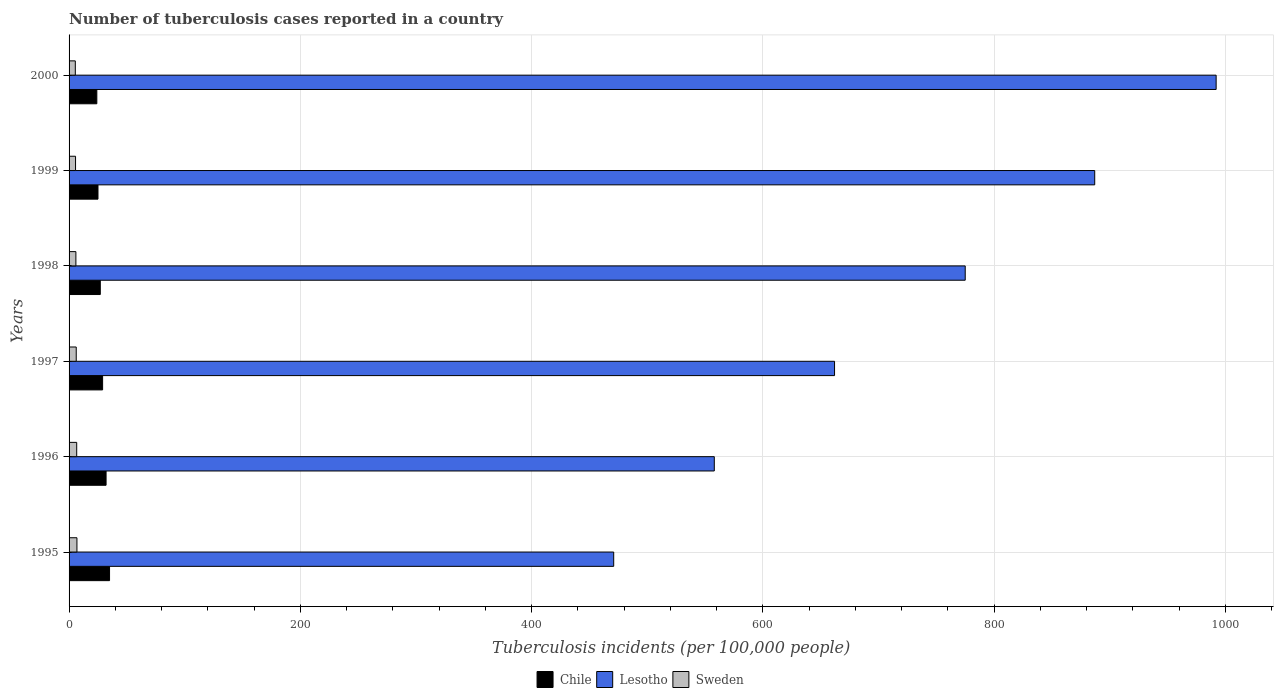How many groups of bars are there?
Keep it short and to the point. 6. Are the number of bars on each tick of the Y-axis equal?
Your answer should be very brief. Yes. How many bars are there on the 6th tick from the top?
Keep it short and to the point. 3. How many bars are there on the 4th tick from the bottom?
Provide a succinct answer. 3. What is the label of the 4th group of bars from the top?
Keep it short and to the point. 1997. What is the number of tuberculosis cases reported in in Chile in 1997?
Provide a succinct answer. 29. Across all years, what is the maximum number of tuberculosis cases reported in in Lesotho?
Offer a terse response. 992. Across all years, what is the minimum number of tuberculosis cases reported in in Chile?
Make the answer very short. 24. What is the total number of tuberculosis cases reported in in Sweden in the graph?
Give a very brief answer. 36.5. What is the difference between the number of tuberculosis cases reported in in Sweden in 1995 and that in 1997?
Keep it short and to the point. 0.6. What is the difference between the number of tuberculosis cases reported in in Chile in 1998 and the number of tuberculosis cases reported in in Sweden in 1997?
Keep it short and to the point. 20.8. What is the average number of tuberculosis cases reported in in Sweden per year?
Your answer should be very brief. 6.08. In the year 1997, what is the difference between the number of tuberculosis cases reported in in Sweden and number of tuberculosis cases reported in in Lesotho?
Ensure brevity in your answer.  -655.8. What is the ratio of the number of tuberculosis cases reported in in Chile in 1996 to that in 1999?
Give a very brief answer. 1.28. Is the number of tuberculosis cases reported in in Lesotho in 1995 less than that in 1999?
Offer a terse response. Yes. What is the difference between the highest and the lowest number of tuberculosis cases reported in in Sweden?
Your response must be concise. 1.4. In how many years, is the number of tuberculosis cases reported in in Chile greater than the average number of tuberculosis cases reported in in Chile taken over all years?
Provide a short and direct response. 3. Is the sum of the number of tuberculosis cases reported in in Chile in 1996 and 1998 greater than the maximum number of tuberculosis cases reported in in Sweden across all years?
Give a very brief answer. Yes. What does the 3rd bar from the bottom in 1996 represents?
Make the answer very short. Sweden. Is it the case that in every year, the sum of the number of tuberculosis cases reported in in Lesotho and number of tuberculosis cases reported in in Sweden is greater than the number of tuberculosis cases reported in in Chile?
Provide a short and direct response. Yes. Are all the bars in the graph horizontal?
Your response must be concise. Yes. What is the difference between two consecutive major ticks on the X-axis?
Give a very brief answer. 200. Are the values on the major ticks of X-axis written in scientific E-notation?
Offer a very short reply. No. Does the graph contain any zero values?
Your answer should be compact. No. Where does the legend appear in the graph?
Provide a short and direct response. Bottom center. How are the legend labels stacked?
Your answer should be compact. Horizontal. What is the title of the graph?
Make the answer very short. Number of tuberculosis cases reported in a country. Does "Singapore" appear as one of the legend labels in the graph?
Your response must be concise. No. What is the label or title of the X-axis?
Your answer should be very brief. Tuberculosis incidents (per 100,0 people). What is the label or title of the Y-axis?
Your answer should be very brief. Years. What is the Tuberculosis incidents (per 100,000 people) in Chile in 1995?
Offer a very short reply. 35. What is the Tuberculosis incidents (per 100,000 people) of Lesotho in 1995?
Provide a short and direct response. 471. What is the Tuberculosis incidents (per 100,000 people) in Chile in 1996?
Make the answer very short. 32. What is the Tuberculosis incidents (per 100,000 people) in Lesotho in 1996?
Your response must be concise. 558. What is the Tuberculosis incidents (per 100,000 people) in Sweden in 1996?
Your answer should be compact. 6.6. What is the Tuberculosis incidents (per 100,000 people) in Chile in 1997?
Provide a succinct answer. 29. What is the Tuberculosis incidents (per 100,000 people) in Lesotho in 1997?
Offer a very short reply. 662. What is the Tuberculosis incidents (per 100,000 people) of Sweden in 1997?
Your answer should be compact. 6.2. What is the Tuberculosis incidents (per 100,000 people) in Lesotho in 1998?
Your answer should be compact. 775. What is the Tuberculosis incidents (per 100,000 people) in Sweden in 1998?
Ensure brevity in your answer.  5.9. What is the Tuberculosis incidents (per 100,000 people) of Lesotho in 1999?
Your answer should be compact. 887. What is the Tuberculosis incidents (per 100,000 people) in Lesotho in 2000?
Your answer should be very brief. 992. What is the Tuberculosis incidents (per 100,000 people) of Sweden in 2000?
Your answer should be very brief. 5.4. Across all years, what is the maximum Tuberculosis incidents (per 100,000 people) of Chile?
Provide a short and direct response. 35. Across all years, what is the maximum Tuberculosis incidents (per 100,000 people) in Lesotho?
Offer a very short reply. 992. Across all years, what is the maximum Tuberculosis incidents (per 100,000 people) of Sweden?
Your answer should be compact. 6.8. Across all years, what is the minimum Tuberculosis incidents (per 100,000 people) in Lesotho?
Ensure brevity in your answer.  471. Across all years, what is the minimum Tuberculosis incidents (per 100,000 people) in Sweden?
Provide a succinct answer. 5.4. What is the total Tuberculosis incidents (per 100,000 people) in Chile in the graph?
Your response must be concise. 172. What is the total Tuberculosis incidents (per 100,000 people) of Lesotho in the graph?
Provide a succinct answer. 4345. What is the total Tuberculosis incidents (per 100,000 people) of Sweden in the graph?
Make the answer very short. 36.5. What is the difference between the Tuberculosis incidents (per 100,000 people) of Chile in 1995 and that in 1996?
Provide a short and direct response. 3. What is the difference between the Tuberculosis incidents (per 100,000 people) of Lesotho in 1995 and that in 1996?
Make the answer very short. -87. What is the difference between the Tuberculosis incidents (per 100,000 people) in Sweden in 1995 and that in 1996?
Your response must be concise. 0.2. What is the difference between the Tuberculosis incidents (per 100,000 people) in Lesotho in 1995 and that in 1997?
Offer a terse response. -191. What is the difference between the Tuberculosis incidents (per 100,000 people) in Sweden in 1995 and that in 1997?
Provide a short and direct response. 0.6. What is the difference between the Tuberculosis incidents (per 100,000 people) of Chile in 1995 and that in 1998?
Your response must be concise. 8. What is the difference between the Tuberculosis incidents (per 100,000 people) of Lesotho in 1995 and that in 1998?
Your answer should be very brief. -304. What is the difference between the Tuberculosis incidents (per 100,000 people) of Sweden in 1995 and that in 1998?
Your answer should be compact. 0.9. What is the difference between the Tuberculosis incidents (per 100,000 people) in Lesotho in 1995 and that in 1999?
Your response must be concise. -416. What is the difference between the Tuberculosis incidents (per 100,000 people) of Chile in 1995 and that in 2000?
Offer a terse response. 11. What is the difference between the Tuberculosis incidents (per 100,000 people) of Lesotho in 1995 and that in 2000?
Provide a short and direct response. -521. What is the difference between the Tuberculosis incidents (per 100,000 people) in Sweden in 1995 and that in 2000?
Offer a very short reply. 1.4. What is the difference between the Tuberculosis incidents (per 100,000 people) of Lesotho in 1996 and that in 1997?
Make the answer very short. -104. What is the difference between the Tuberculosis incidents (per 100,000 people) in Sweden in 1996 and that in 1997?
Offer a terse response. 0.4. What is the difference between the Tuberculosis incidents (per 100,000 people) in Chile in 1996 and that in 1998?
Give a very brief answer. 5. What is the difference between the Tuberculosis incidents (per 100,000 people) in Lesotho in 1996 and that in 1998?
Make the answer very short. -217. What is the difference between the Tuberculosis incidents (per 100,000 people) of Sweden in 1996 and that in 1998?
Offer a very short reply. 0.7. What is the difference between the Tuberculosis incidents (per 100,000 people) of Lesotho in 1996 and that in 1999?
Give a very brief answer. -329. What is the difference between the Tuberculosis incidents (per 100,000 people) of Chile in 1996 and that in 2000?
Offer a very short reply. 8. What is the difference between the Tuberculosis incidents (per 100,000 people) in Lesotho in 1996 and that in 2000?
Make the answer very short. -434. What is the difference between the Tuberculosis incidents (per 100,000 people) in Sweden in 1996 and that in 2000?
Keep it short and to the point. 1.2. What is the difference between the Tuberculosis incidents (per 100,000 people) of Lesotho in 1997 and that in 1998?
Offer a very short reply. -113. What is the difference between the Tuberculosis incidents (per 100,000 people) in Sweden in 1997 and that in 1998?
Make the answer very short. 0.3. What is the difference between the Tuberculosis incidents (per 100,000 people) in Chile in 1997 and that in 1999?
Ensure brevity in your answer.  4. What is the difference between the Tuberculosis incidents (per 100,000 people) in Lesotho in 1997 and that in 1999?
Offer a terse response. -225. What is the difference between the Tuberculosis incidents (per 100,000 people) in Chile in 1997 and that in 2000?
Your answer should be compact. 5. What is the difference between the Tuberculosis incidents (per 100,000 people) in Lesotho in 1997 and that in 2000?
Offer a very short reply. -330. What is the difference between the Tuberculosis incidents (per 100,000 people) of Sweden in 1997 and that in 2000?
Your answer should be compact. 0.8. What is the difference between the Tuberculosis incidents (per 100,000 people) of Chile in 1998 and that in 1999?
Your answer should be very brief. 2. What is the difference between the Tuberculosis incidents (per 100,000 people) in Lesotho in 1998 and that in 1999?
Offer a terse response. -112. What is the difference between the Tuberculosis incidents (per 100,000 people) in Sweden in 1998 and that in 1999?
Offer a very short reply. 0.3. What is the difference between the Tuberculosis incidents (per 100,000 people) in Chile in 1998 and that in 2000?
Make the answer very short. 3. What is the difference between the Tuberculosis incidents (per 100,000 people) of Lesotho in 1998 and that in 2000?
Ensure brevity in your answer.  -217. What is the difference between the Tuberculosis incidents (per 100,000 people) of Sweden in 1998 and that in 2000?
Offer a terse response. 0.5. What is the difference between the Tuberculosis incidents (per 100,000 people) in Chile in 1999 and that in 2000?
Provide a short and direct response. 1. What is the difference between the Tuberculosis incidents (per 100,000 people) of Lesotho in 1999 and that in 2000?
Keep it short and to the point. -105. What is the difference between the Tuberculosis incidents (per 100,000 people) in Chile in 1995 and the Tuberculosis incidents (per 100,000 people) in Lesotho in 1996?
Your answer should be very brief. -523. What is the difference between the Tuberculosis incidents (per 100,000 people) of Chile in 1995 and the Tuberculosis incidents (per 100,000 people) of Sweden in 1996?
Keep it short and to the point. 28.4. What is the difference between the Tuberculosis incidents (per 100,000 people) of Lesotho in 1995 and the Tuberculosis incidents (per 100,000 people) of Sweden in 1996?
Make the answer very short. 464.4. What is the difference between the Tuberculosis incidents (per 100,000 people) of Chile in 1995 and the Tuberculosis incidents (per 100,000 people) of Lesotho in 1997?
Ensure brevity in your answer.  -627. What is the difference between the Tuberculosis incidents (per 100,000 people) of Chile in 1995 and the Tuberculosis incidents (per 100,000 people) of Sweden in 1997?
Ensure brevity in your answer.  28.8. What is the difference between the Tuberculosis incidents (per 100,000 people) in Lesotho in 1995 and the Tuberculosis incidents (per 100,000 people) in Sweden in 1997?
Your answer should be compact. 464.8. What is the difference between the Tuberculosis incidents (per 100,000 people) of Chile in 1995 and the Tuberculosis incidents (per 100,000 people) of Lesotho in 1998?
Keep it short and to the point. -740. What is the difference between the Tuberculosis incidents (per 100,000 people) of Chile in 1995 and the Tuberculosis incidents (per 100,000 people) of Sweden in 1998?
Your response must be concise. 29.1. What is the difference between the Tuberculosis incidents (per 100,000 people) in Lesotho in 1995 and the Tuberculosis incidents (per 100,000 people) in Sweden in 1998?
Offer a very short reply. 465.1. What is the difference between the Tuberculosis incidents (per 100,000 people) in Chile in 1995 and the Tuberculosis incidents (per 100,000 people) in Lesotho in 1999?
Your response must be concise. -852. What is the difference between the Tuberculosis incidents (per 100,000 people) of Chile in 1995 and the Tuberculosis incidents (per 100,000 people) of Sweden in 1999?
Give a very brief answer. 29.4. What is the difference between the Tuberculosis incidents (per 100,000 people) of Lesotho in 1995 and the Tuberculosis incidents (per 100,000 people) of Sweden in 1999?
Give a very brief answer. 465.4. What is the difference between the Tuberculosis incidents (per 100,000 people) of Chile in 1995 and the Tuberculosis incidents (per 100,000 people) of Lesotho in 2000?
Keep it short and to the point. -957. What is the difference between the Tuberculosis incidents (per 100,000 people) in Chile in 1995 and the Tuberculosis incidents (per 100,000 people) in Sweden in 2000?
Provide a succinct answer. 29.6. What is the difference between the Tuberculosis incidents (per 100,000 people) of Lesotho in 1995 and the Tuberculosis incidents (per 100,000 people) of Sweden in 2000?
Provide a short and direct response. 465.6. What is the difference between the Tuberculosis incidents (per 100,000 people) in Chile in 1996 and the Tuberculosis incidents (per 100,000 people) in Lesotho in 1997?
Your response must be concise. -630. What is the difference between the Tuberculosis incidents (per 100,000 people) of Chile in 1996 and the Tuberculosis incidents (per 100,000 people) of Sweden in 1997?
Offer a terse response. 25.8. What is the difference between the Tuberculosis incidents (per 100,000 people) in Lesotho in 1996 and the Tuberculosis incidents (per 100,000 people) in Sweden in 1997?
Offer a terse response. 551.8. What is the difference between the Tuberculosis incidents (per 100,000 people) in Chile in 1996 and the Tuberculosis incidents (per 100,000 people) in Lesotho in 1998?
Your answer should be compact. -743. What is the difference between the Tuberculosis incidents (per 100,000 people) of Chile in 1996 and the Tuberculosis incidents (per 100,000 people) of Sweden in 1998?
Offer a very short reply. 26.1. What is the difference between the Tuberculosis incidents (per 100,000 people) of Lesotho in 1996 and the Tuberculosis incidents (per 100,000 people) of Sweden in 1998?
Ensure brevity in your answer.  552.1. What is the difference between the Tuberculosis incidents (per 100,000 people) in Chile in 1996 and the Tuberculosis incidents (per 100,000 people) in Lesotho in 1999?
Offer a terse response. -855. What is the difference between the Tuberculosis incidents (per 100,000 people) of Chile in 1996 and the Tuberculosis incidents (per 100,000 people) of Sweden in 1999?
Ensure brevity in your answer.  26.4. What is the difference between the Tuberculosis incidents (per 100,000 people) in Lesotho in 1996 and the Tuberculosis incidents (per 100,000 people) in Sweden in 1999?
Keep it short and to the point. 552.4. What is the difference between the Tuberculosis incidents (per 100,000 people) of Chile in 1996 and the Tuberculosis incidents (per 100,000 people) of Lesotho in 2000?
Make the answer very short. -960. What is the difference between the Tuberculosis incidents (per 100,000 people) in Chile in 1996 and the Tuberculosis incidents (per 100,000 people) in Sweden in 2000?
Provide a short and direct response. 26.6. What is the difference between the Tuberculosis incidents (per 100,000 people) in Lesotho in 1996 and the Tuberculosis incidents (per 100,000 people) in Sweden in 2000?
Offer a terse response. 552.6. What is the difference between the Tuberculosis incidents (per 100,000 people) in Chile in 1997 and the Tuberculosis incidents (per 100,000 people) in Lesotho in 1998?
Your response must be concise. -746. What is the difference between the Tuberculosis incidents (per 100,000 people) of Chile in 1997 and the Tuberculosis incidents (per 100,000 people) of Sweden in 1998?
Keep it short and to the point. 23.1. What is the difference between the Tuberculosis incidents (per 100,000 people) of Lesotho in 1997 and the Tuberculosis incidents (per 100,000 people) of Sweden in 1998?
Keep it short and to the point. 656.1. What is the difference between the Tuberculosis incidents (per 100,000 people) of Chile in 1997 and the Tuberculosis incidents (per 100,000 people) of Lesotho in 1999?
Keep it short and to the point. -858. What is the difference between the Tuberculosis incidents (per 100,000 people) of Chile in 1997 and the Tuberculosis incidents (per 100,000 people) of Sweden in 1999?
Your answer should be compact. 23.4. What is the difference between the Tuberculosis incidents (per 100,000 people) of Lesotho in 1997 and the Tuberculosis incidents (per 100,000 people) of Sweden in 1999?
Offer a terse response. 656.4. What is the difference between the Tuberculosis incidents (per 100,000 people) of Chile in 1997 and the Tuberculosis incidents (per 100,000 people) of Lesotho in 2000?
Provide a succinct answer. -963. What is the difference between the Tuberculosis incidents (per 100,000 people) in Chile in 1997 and the Tuberculosis incidents (per 100,000 people) in Sweden in 2000?
Your response must be concise. 23.6. What is the difference between the Tuberculosis incidents (per 100,000 people) in Lesotho in 1997 and the Tuberculosis incidents (per 100,000 people) in Sweden in 2000?
Give a very brief answer. 656.6. What is the difference between the Tuberculosis incidents (per 100,000 people) in Chile in 1998 and the Tuberculosis incidents (per 100,000 people) in Lesotho in 1999?
Offer a terse response. -860. What is the difference between the Tuberculosis incidents (per 100,000 people) of Chile in 1998 and the Tuberculosis incidents (per 100,000 people) of Sweden in 1999?
Your answer should be compact. 21.4. What is the difference between the Tuberculosis incidents (per 100,000 people) in Lesotho in 1998 and the Tuberculosis incidents (per 100,000 people) in Sweden in 1999?
Give a very brief answer. 769.4. What is the difference between the Tuberculosis incidents (per 100,000 people) in Chile in 1998 and the Tuberculosis incidents (per 100,000 people) in Lesotho in 2000?
Ensure brevity in your answer.  -965. What is the difference between the Tuberculosis incidents (per 100,000 people) in Chile in 1998 and the Tuberculosis incidents (per 100,000 people) in Sweden in 2000?
Offer a very short reply. 21.6. What is the difference between the Tuberculosis incidents (per 100,000 people) of Lesotho in 1998 and the Tuberculosis incidents (per 100,000 people) of Sweden in 2000?
Offer a very short reply. 769.6. What is the difference between the Tuberculosis incidents (per 100,000 people) of Chile in 1999 and the Tuberculosis incidents (per 100,000 people) of Lesotho in 2000?
Ensure brevity in your answer.  -967. What is the difference between the Tuberculosis incidents (per 100,000 people) in Chile in 1999 and the Tuberculosis incidents (per 100,000 people) in Sweden in 2000?
Offer a very short reply. 19.6. What is the difference between the Tuberculosis incidents (per 100,000 people) in Lesotho in 1999 and the Tuberculosis incidents (per 100,000 people) in Sweden in 2000?
Keep it short and to the point. 881.6. What is the average Tuberculosis incidents (per 100,000 people) in Chile per year?
Make the answer very short. 28.67. What is the average Tuberculosis incidents (per 100,000 people) in Lesotho per year?
Provide a succinct answer. 724.17. What is the average Tuberculosis incidents (per 100,000 people) in Sweden per year?
Your answer should be very brief. 6.08. In the year 1995, what is the difference between the Tuberculosis incidents (per 100,000 people) of Chile and Tuberculosis incidents (per 100,000 people) of Lesotho?
Your response must be concise. -436. In the year 1995, what is the difference between the Tuberculosis incidents (per 100,000 people) of Chile and Tuberculosis incidents (per 100,000 people) of Sweden?
Ensure brevity in your answer.  28.2. In the year 1995, what is the difference between the Tuberculosis incidents (per 100,000 people) of Lesotho and Tuberculosis incidents (per 100,000 people) of Sweden?
Ensure brevity in your answer.  464.2. In the year 1996, what is the difference between the Tuberculosis incidents (per 100,000 people) of Chile and Tuberculosis incidents (per 100,000 people) of Lesotho?
Provide a succinct answer. -526. In the year 1996, what is the difference between the Tuberculosis incidents (per 100,000 people) in Chile and Tuberculosis incidents (per 100,000 people) in Sweden?
Provide a succinct answer. 25.4. In the year 1996, what is the difference between the Tuberculosis incidents (per 100,000 people) in Lesotho and Tuberculosis incidents (per 100,000 people) in Sweden?
Provide a short and direct response. 551.4. In the year 1997, what is the difference between the Tuberculosis incidents (per 100,000 people) of Chile and Tuberculosis incidents (per 100,000 people) of Lesotho?
Keep it short and to the point. -633. In the year 1997, what is the difference between the Tuberculosis incidents (per 100,000 people) of Chile and Tuberculosis incidents (per 100,000 people) of Sweden?
Provide a short and direct response. 22.8. In the year 1997, what is the difference between the Tuberculosis incidents (per 100,000 people) of Lesotho and Tuberculosis incidents (per 100,000 people) of Sweden?
Make the answer very short. 655.8. In the year 1998, what is the difference between the Tuberculosis incidents (per 100,000 people) in Chile and Tuberculosis incidents (per 100,000 people) in Lesotho?
Make the answer very short. -748. In the year 1998, what is the difference between the Tuberculosis incidents (per 100,000 people) in Chile and Tuberculosis incidents (per 100,000 people) in Sweden?
Your answer should be very brief. 21.1. In the year 1998, what is the difference between the Tuberculosis incidents (per 100,000 people) of Lesotho and Tuberculosis incidents (per 100,000 people) of Sweden?
Your answer should be very brief. 769.1. In the year 1999, what is the difference between the Tuberculosis incidents (per 100,000 people) of Chile and Tuberculosis incidents (per 100,000 people) of Lesotho?
Your answer should be compact. -862. In the year 1999, what is the difference between the Tuberculosis incidents (per 100,000 people) of Chile and Tuberculosis incidents (per 100,000 people) of Sweden?
Ensure brevity in your answer.  19.4. In the year 1999, what is the difference between the Tuberculosis incidents (per 100,000 people) of Lesotho and Tuberculosis incidents (per 100,000 people) of Sweden?
Your response must be concise. 881.4. In the year 2000, what is the difference between the Tuberculosis incidents (per 100,000 people) of Chile and Tuberculosis incidents (per 100,000 people) of Lesotho?
Ensure brevity in your answer.  -968. In the year 2000, what is the difference between the Tuberculosis incidents (per 100,000 people) in Chile and Tuberculosis incidents (per 100,000 people) in Sweden?
Offer a very short reply. 18.6. In the year 2000, what is the difference between the Tuberculosis incidents (per 100,000 people) in Lesotho and Tuberculosis incidents (per 100,000 people) in Sweden?
Provide a succinct answer. 986.6. What is the ratio of the Tuberculosis incidents (per 100,000 people) of Chile in 1995 to that in 1996?
Offer a terse response. 1.09. What is the ratio of the Tuberculosis incidents (per 100,000 people) of Lesotho in 1995 to that in 1996?
Give a very brief answer. 0.84. What is the ratio of the Tuberculosis incidents (per 100,000 people) of Sweden in 1995 to that in 1996?
Make the answer very short. 1.03. What is the ratio of the Tuberculosis incidents (per 100,000 people) in Chile in 1995 to that in 1997?
Your answer should be very brief. 1.21. What is the ratio of the Tuberculosis incidents (per 100,000 people) of Lesotho in 1995 to that in 1997?
Make the answer very short. 0.71. What is the ratio of the Tuberculosis incidents (per 100,000 people) in Sweden in 1995 to that in 1997?
Offer a very short reply. 1.1. What is the ratio of the Tuberculosis incidents (per 100,000 people) of Chile in 1995 to that in 1998?
Your response must be concise. 1.3. What is the ratio of the Tuberculosis incidents (per 100,000 people) of Lesotho in 1995 to that in 1998?
Offer a very short reply. 0.61. What is the ratio of the Tuberculosis incidents (per 100,000 people) in Sweden in 1995 to that in 1998?
Keep it short and to the point. 1.15. What is the ratio of the Tuberculosis incidents (per 100,000 people) in Lesotho in 1995 to that in 1999?
Provide a short and direct response. 0.53. What is the ratio of the Tuberculosis incidents (per 100,000 people) of Sweden in 1995 to that in 1999?
Give a very brief answer. 1.21. What is the ratio of the Tuberculosis incidents (per 100,000 people) of Chile in 1995 to that in 2000?
Offer a terse response. 1.46. What is the ratio of the Tuberculosis incidents (per 100,000 people) in Lesotho in 1995 to that in 2000?
Ensure brevity in your answer.  0.47. What is the ratio of the Tuberculosis incidents (per 100,000 people) of Sweden in 1995 to that in 2000?
Your answer should be compact. 1.26. What is the ratio of the Tuberculosis incidents (per 100,000 people) of Chile in 1996 to that in 1997?
Ensure brevity in your answer.  1.1. What is the ratio of the Tuberculosis incidents (per 100,000 people) of Lesotho in 1996 to that in 1997?
Provide a succinct answer. 0.84. What is the ratio of the Tuberculosis incidents (per 100,000 people) in Sweden in 1996 to that in 1997?
Provide a short and direct response. 1.06. What is the ratio of the Tuberculosis incidents (per 100,000 people) of Chile in 1996 to that in 1998?
Provide a short and direct response. 1.19. What is the ratio of the Tuberculosis incidents (per 100,000 people) in Lesotho in 1996 to that in 1998?
Provide a succinct answer. 0.72. What is the ratio of the Tuberculosis incidents (per 100,000 people) of Sweden in 1996 to that in 1998?
Give a very brief answer. 1.12. What is the ratio of the Tuberculosis incidents (per 100,000 people) of Chile in 1996 to that in 1999?
Make the answer very short. 1.28. What is the ratio of the Tuberculosis incidents (per 100,000 people) of Lesotho in 1996 to that in 1999?
Your answer should be very brief. 0.63. What is the ratio of the Tuberculosis incidents (per 100,000 people) of Sweden in 1996 to that in 1999?
Give a very brief answer. 1.18. What is the ratio of the Tuberculosis incidents (per 100,000 people) in Chile in 1996 to that in 2000?
Make the answer very short. 1.33. What is the ratio of the Tuberculosis incidents (per 100,000 people) of Lesotho in 1996 to that in 2000?
Your response must be concise. 0.56. What is the ratio of the Tuberculosis incidents (per 100,000 people) in Sweden in 1996 to that in 2000?
Offer a very short reply. 1.22. What is the ratio of the Tuberculosis incidents (per 100,000 people) in Chile in 1997 to that in 1998?
Keep it short and to the point. 1.07. What is the ratio of the Tuberculosis incidents (per 100,000 people) of Lesotho in 1997 to that in 1998?
Offer a very short reply. 0.85. What is the ratio of the Tuberculosis incidents (per 100,000 people) in Sweden in 1997 to that in 1998?
Offer a very short reply. 1.05. What is the ratio of the Tuberculosis incidents (per 100,000 people) in Chile in 1997 to that in 1999?
Your response must be concise. 1.16. What is the ratio of the Tuberculosis incidents (per 100,000 people) in Lesotho in 1997 to that in 1999?
Provide a short and direct response. 0.75. What is the ratio of the Tuberculosis incidents (per 100,000 people) of Sweden in 1997 to that in 1999?
Provide a short and direct response. 1.11. What is the ratio of the Tuberculosis incidents (per 100,000 people) in Chile in 1997 to that in 2000?
Ensure brevity in your answer.  1.21. What is the ratio of the Tuberculosis incidents (per 100,000 people) in Lesotho in 1997 to that in 2000?
Keep it short and to the point. 0.67. What is the ratio of the Tuberculosis incidents (per 100,000 people) in Sweden in 1997 to that in 2000?
Your answer should be very brief. 1.15. What is the ratio of the Tuberculosis incidents (per 100,000 people) of Lesotho in 1998 to that in 1999?
Ensure brevity in your answer.  0.87. What is the ratio of the Tuberculosis incidents (per 100,000 people) in Sweden in 1998 to that in 1999?
Give a very brief answer. 1.05. What is the ratio of the Tuberculosis incidents (per 100,000 people) in Chile in 1998 to that in 2000?
Give a very brief answer. 1.12. What is the ratio of the Tuberculosis incidents (per 100,000 people) of Lesotho in 1998 to that in 2000?
Make the answer very short. 0.78. What is the ratio of the Tuberculosis incidents (per 100,000 people) of Sweden in 1998 to that in 2000?
Provide a succinct answer. 1.09. What is the ratio of the Tuberculosis incidents (per 100,000 people) of Chile in 1999 to that in 2000?
Give a very brief answer. 1.04. What is the ratio of the Tuberculosis incidents (per 100,000 people) of Lesotho in 1999 to that in 2000?
Offer a terse response. 0.89. What is the difference between the highest and the second highest Tuberculosis incidents (per 100,000 people) in Lesotho?
Your answer should be very brief. 105. What is the difference between the highest and the second highest Tuberculosis incidents (per 100,000 people) in Sweden?
Keep it short and to the point. 0.2. What is the difference between the highest and the lowest Tuberculosis incidents (per 100,000 people) in Chile?
Provide a short and direct response. 11. What is the difference between the highest and the lowest Tuberculosis incidents (per 100,000 people) of Lesotho?
Your answer should be compact. 521. 